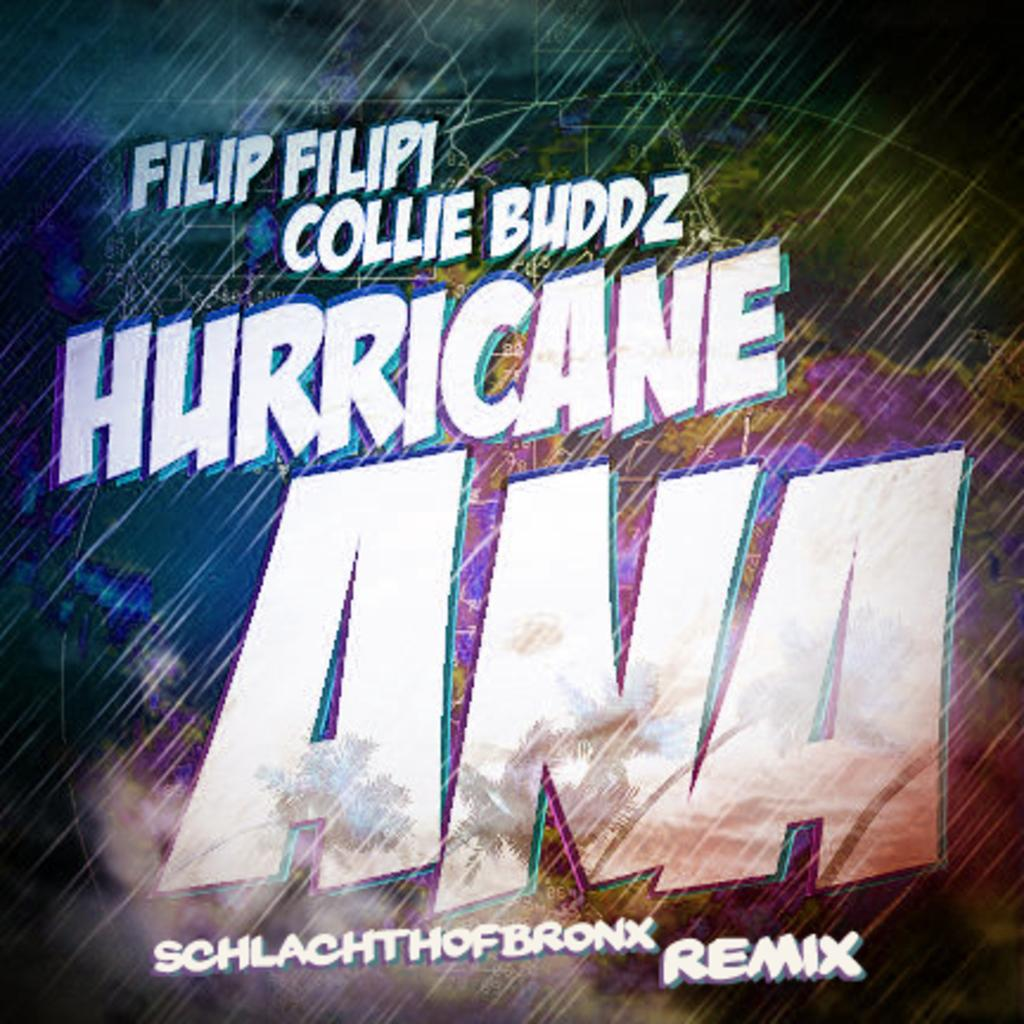<image>
Write a terse but informative summary of the picture. The cover an album entitled Hurricane Ana Remix. 